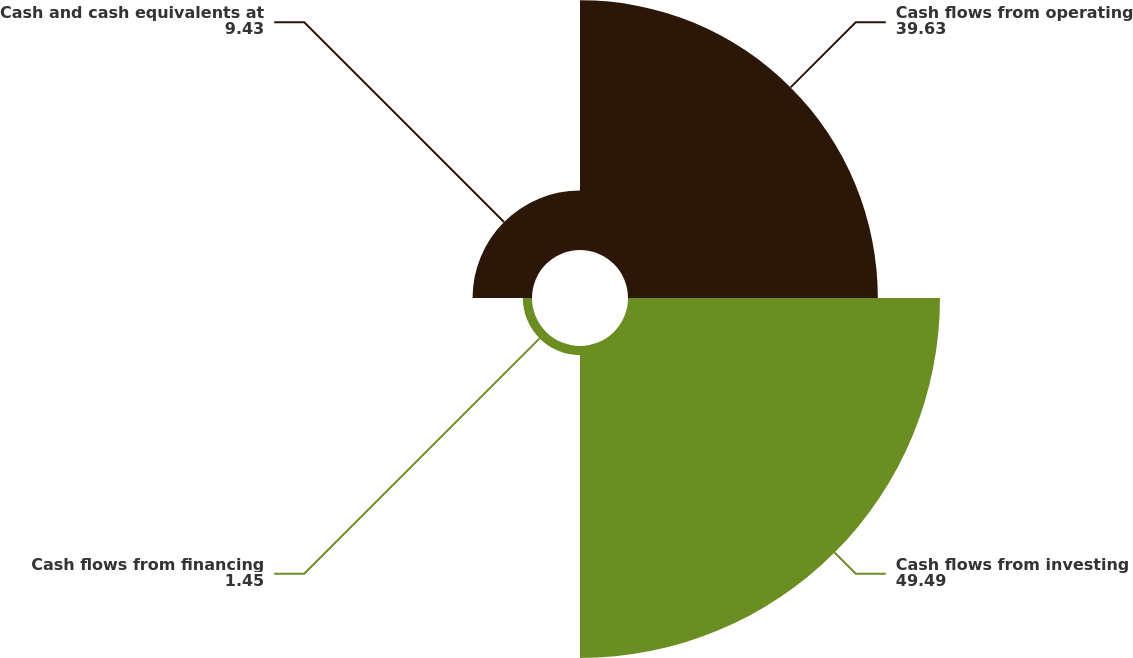Convert chart. <chart><loc_0><loc_0><loc_500><loc_500><pie_chart><fcel>Cash flows from operating<fcel>Cash flows from investing<fcel>Cash flows from financing<fcel>Cash and cash equivalents at<nl><fcel>39.63%<fcel>49.49%<fcel>1.45%<fcel>9.43%<nl></chart> 